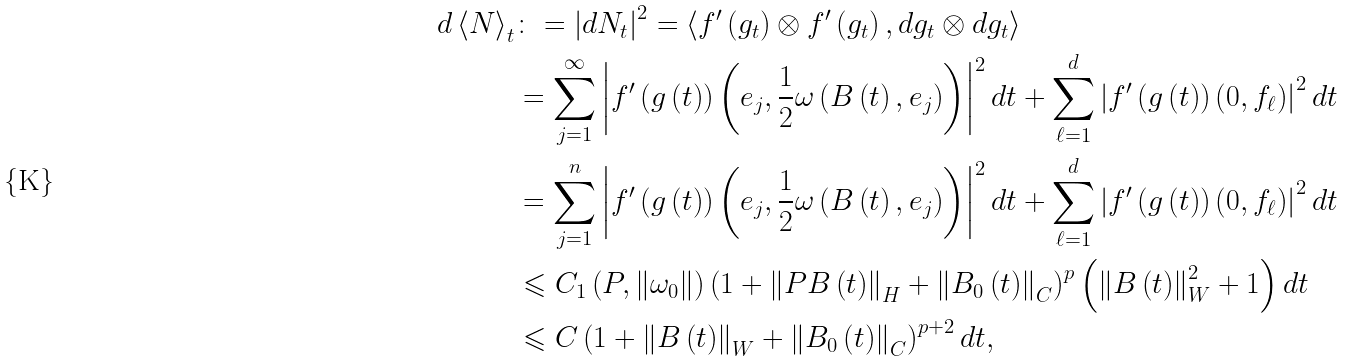<formula> <loc_0><loc_0><loc_500><loc_500>d \left \langle N \right \rangle _ { t } & \colon = \left | d N _ { t } \right | ^ { 2 } = \left \langle f ^ { \prime } \left ( g _ { t } \right ) \otimes f ^ { \prime } \left ( g _ { t } \right ) , d g _ { t } \otimes d g _ { t } \right \rangle \\ & = \sum _ { j = 1 } ^ { \infty } \left | f ^ { \prime } \left ( g \left ( t \right ) \right ) \left ( e _ { j } , \frac { 1 } { 2 } \omega \left ( B \left ( t \right ) , e _ { j } \right ) \right ) \right | ^ { 2 } d t + \sum _ { \ell = 1 } ^ { d } \left | f ^ { \prime } \left ( g \left ( t \right ) \right ) \left ( 0 , f _ { \ell } \right ) \right | ^ { 2 } d t \\ & = \sum _ { j = 1 } ^ { n } \left | f ^ { \prime } \left ( g \left ( t \right ) \right ) \left ( e _ { j } , \frac { 1 } { 2 } \omega \left ( B \left ( t \right ) , e _ { j } \right ) \right ) \right | ^ { 2 } d t + \sum _ { \ell = 1 } ^ { d } \left | f ^ { \prime } \left ( g \left ( t \right ) \right ) \left ( 0 , f _ { \ell } \right ) \right | ^ { 2 } d t \\ & \leqslant C _ { 1 } \left ( P , \left \| \omega _ { 0 } \right \| \right ) \left ( 1 + \left \| P B \left ( t \right ) \right \| _ { H } + \left \| B _ { 0 } \left ( t \right ) \right \| _ { C } \right ) ^ { p } \left ( \left \| B \left ( t \right ) \right \| _ { W } ^ { 2 } + 1 \right ) d t \\ & \leqslant C \left ( 1 + \left \| B \left ( t \right ) \right \| _ { W } + \left \| B _ { 0 } \left ( t \right ) \right \| _ { C } \right ) ^ { p + 2 } d t ,</formula> 